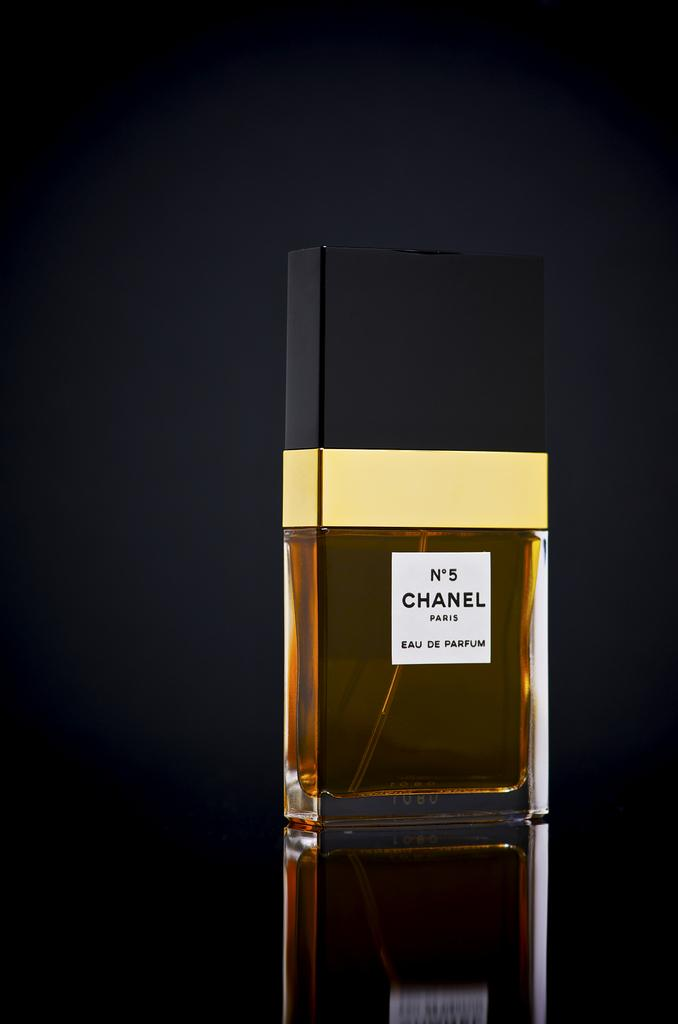<image>
Give a short and clear explanation of the subsequent image. A bottle of No5 chanel perfume sits in front of a black background. 